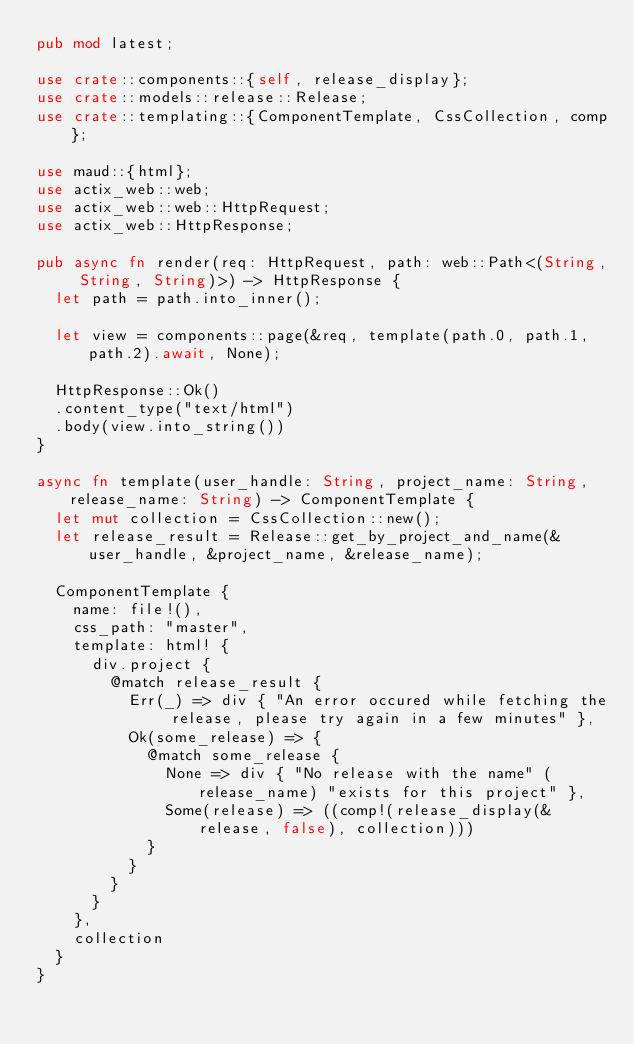Convert code to text. <code><loc_0><loc_0><loc_500><loc_500><_Rust_>pub mod latest;

use crate::components::{self, release_display};
use crate::models::release::Release;
use crate::templating::{ComponentTemplate, CssCollection, comp};

use maud::{html};
use actix_web::web;
use actix_web::web::HttpRequest;
use actix_web::HttpResponse;

pub async fn render(req: HttpRequest, path: web::Path<(String, String, String)>) -> HttpResponse {
  let path = path.into_inner();

  let view = components::page(&req, template(path.0, path.1, path.2).await, None);
  
  HttpResponse::Ok()
  .content_type("text/html")
  .body(view.into_string())
}

async fn template(user_handle: String, project_name: String, release_name: String) -> ComponentTemplate {
  let mut collection = CssCollection::new();
  let release_result = Release::get_by_project_and_name(&user_handle, &project_name, &release_name);

  ComponentTemplate {
    name: file!(),
    css_path: "master",
    template: html! {
      div.project {
        @match release_result {
          Err(_) => div { "An error occured while fetching the release, please try again in a few minutes" },
          Ok(some_release) => {
            @match some_release {
              None => div { "No release with the name" (release_name) "exists for this project" },
              Some(release) => ((comp!(release_display(&release, false), collection)))
            }
          }
        }
      }
    },
    collection
  }
}</code> 